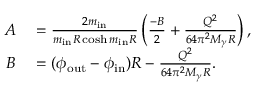Convert formula to latex. <formula><loc_0><loc_0><loc_500><loc_500>\begin{array} { r l } { A } & = \frac { 2 m _ { i n } } { m _ { i n } R \cosh m _ { i n } R } \left ( \frac { - B } { 2 } + \frac { Q ^ { 2 } } { 6 4 \pi ^ { 2 } M _ { \gamma } R } \right ) , } \\ { B } & = ( \phi _ { o u t } - \phi _ { i n } ) R - \frac { Q ^ { 2 } } { 6 4 \pi ^ { 2 } M _ { \gamma } R } . } \end{array}</formula> 